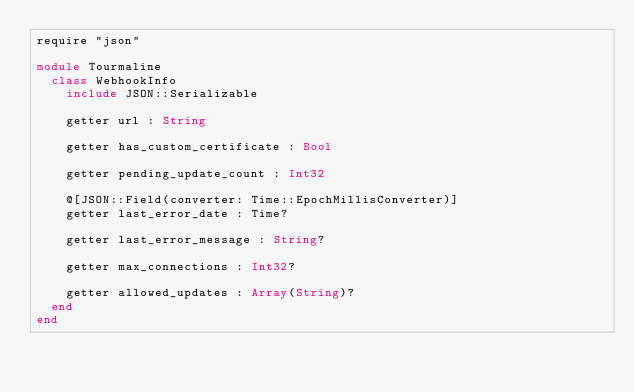Convert code to text. <code><loc_0><loc_0><loc_500><loc_500><_Crystal_>require "json"

module Tourmaline
  class WebhookInfo
    include JSON::Serializable

    getter url : String

    getter has_custom_certificate : Bool

    getter pending_update_count : Int32

    @[JSON::Field(converter: Time::EpochMillisConverter)]
    getter last_error_date : Time?

    getter last_error_message : String?

    getter max_connections : Int32?

    getter allowed_updates : Array(String)?
  end
end
</code> 